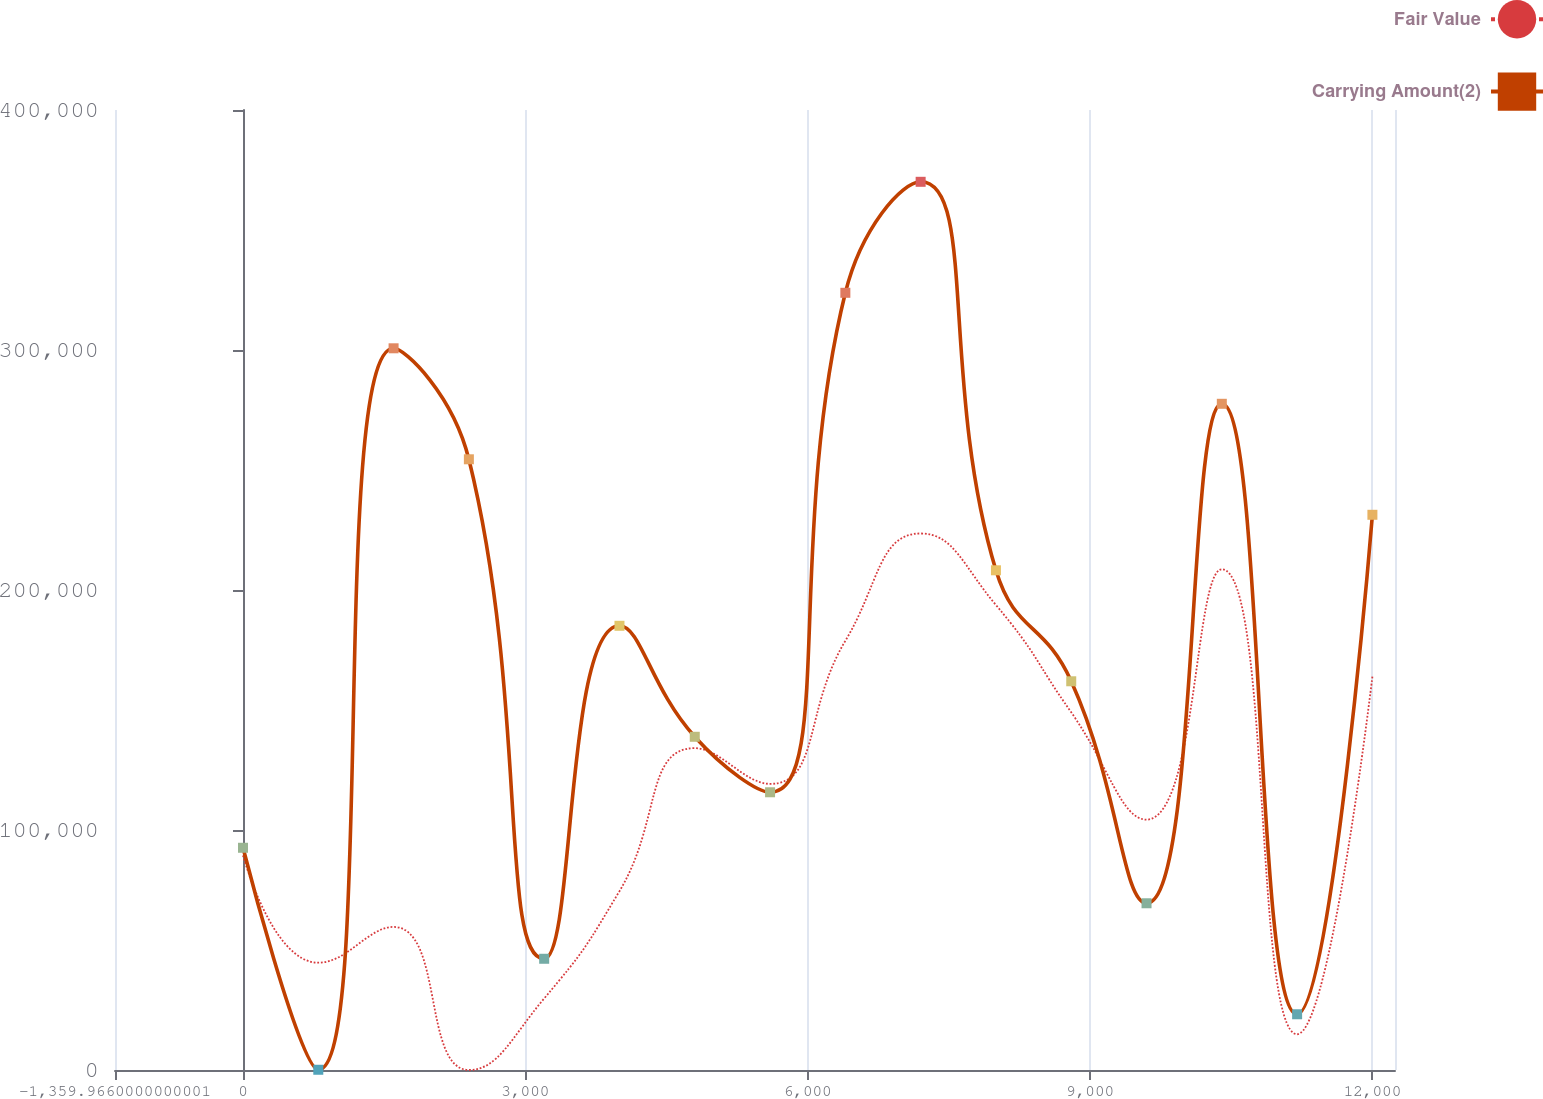<chart> <loc_0><loc_0><loc_500><loc_500><line_chart><ecel><fcel>Fair Value<fcel>Carrying Amount(2)<nl><fcel>0<fcel>89417.7<fcel>92595<nl><fcel>799.98<fcel>44708.9<fcel>99.67<nl><fcel>1599.96<fcel>59611.8<fcel>300710<nl><fcel>2399.94<fcel>0<fcel>254462<nl><fcel>3199.92<fcel>29805.9<fcel>46347.3<nl><fcel>3999.9<fcel>74514.8<fcel>185090<nl><fcel>4799.88<fcel>134127<fcel>138843<nl><fcel>5599.86<fcel>119224<fcel>115719<nl><fcel>6399.84<fcel>178835<fcel>323833<nl><fcel>7199.82<fcel>223544<fcel>370081<nl><fcel>7999.8<fcel>193738<fcel>208214<nl><fcel>8799.78<fcel>149030<fcel>161967<nl><fcel>9599.76<fcel>104321<fcel>69471.2<nl><fcel>10399.7<fcel>208641<fcel>277586<nl><fcel>11199.7<fcel>14903<fcel>23223.5<nl><fcel>11999.7<fcel>163932<fcel>231338<nl><fcel>12799.7<fcel>238447<fcel>346957<nl><fcel>13599.7<fcel>253350<fcel>393205<nl></chart> 